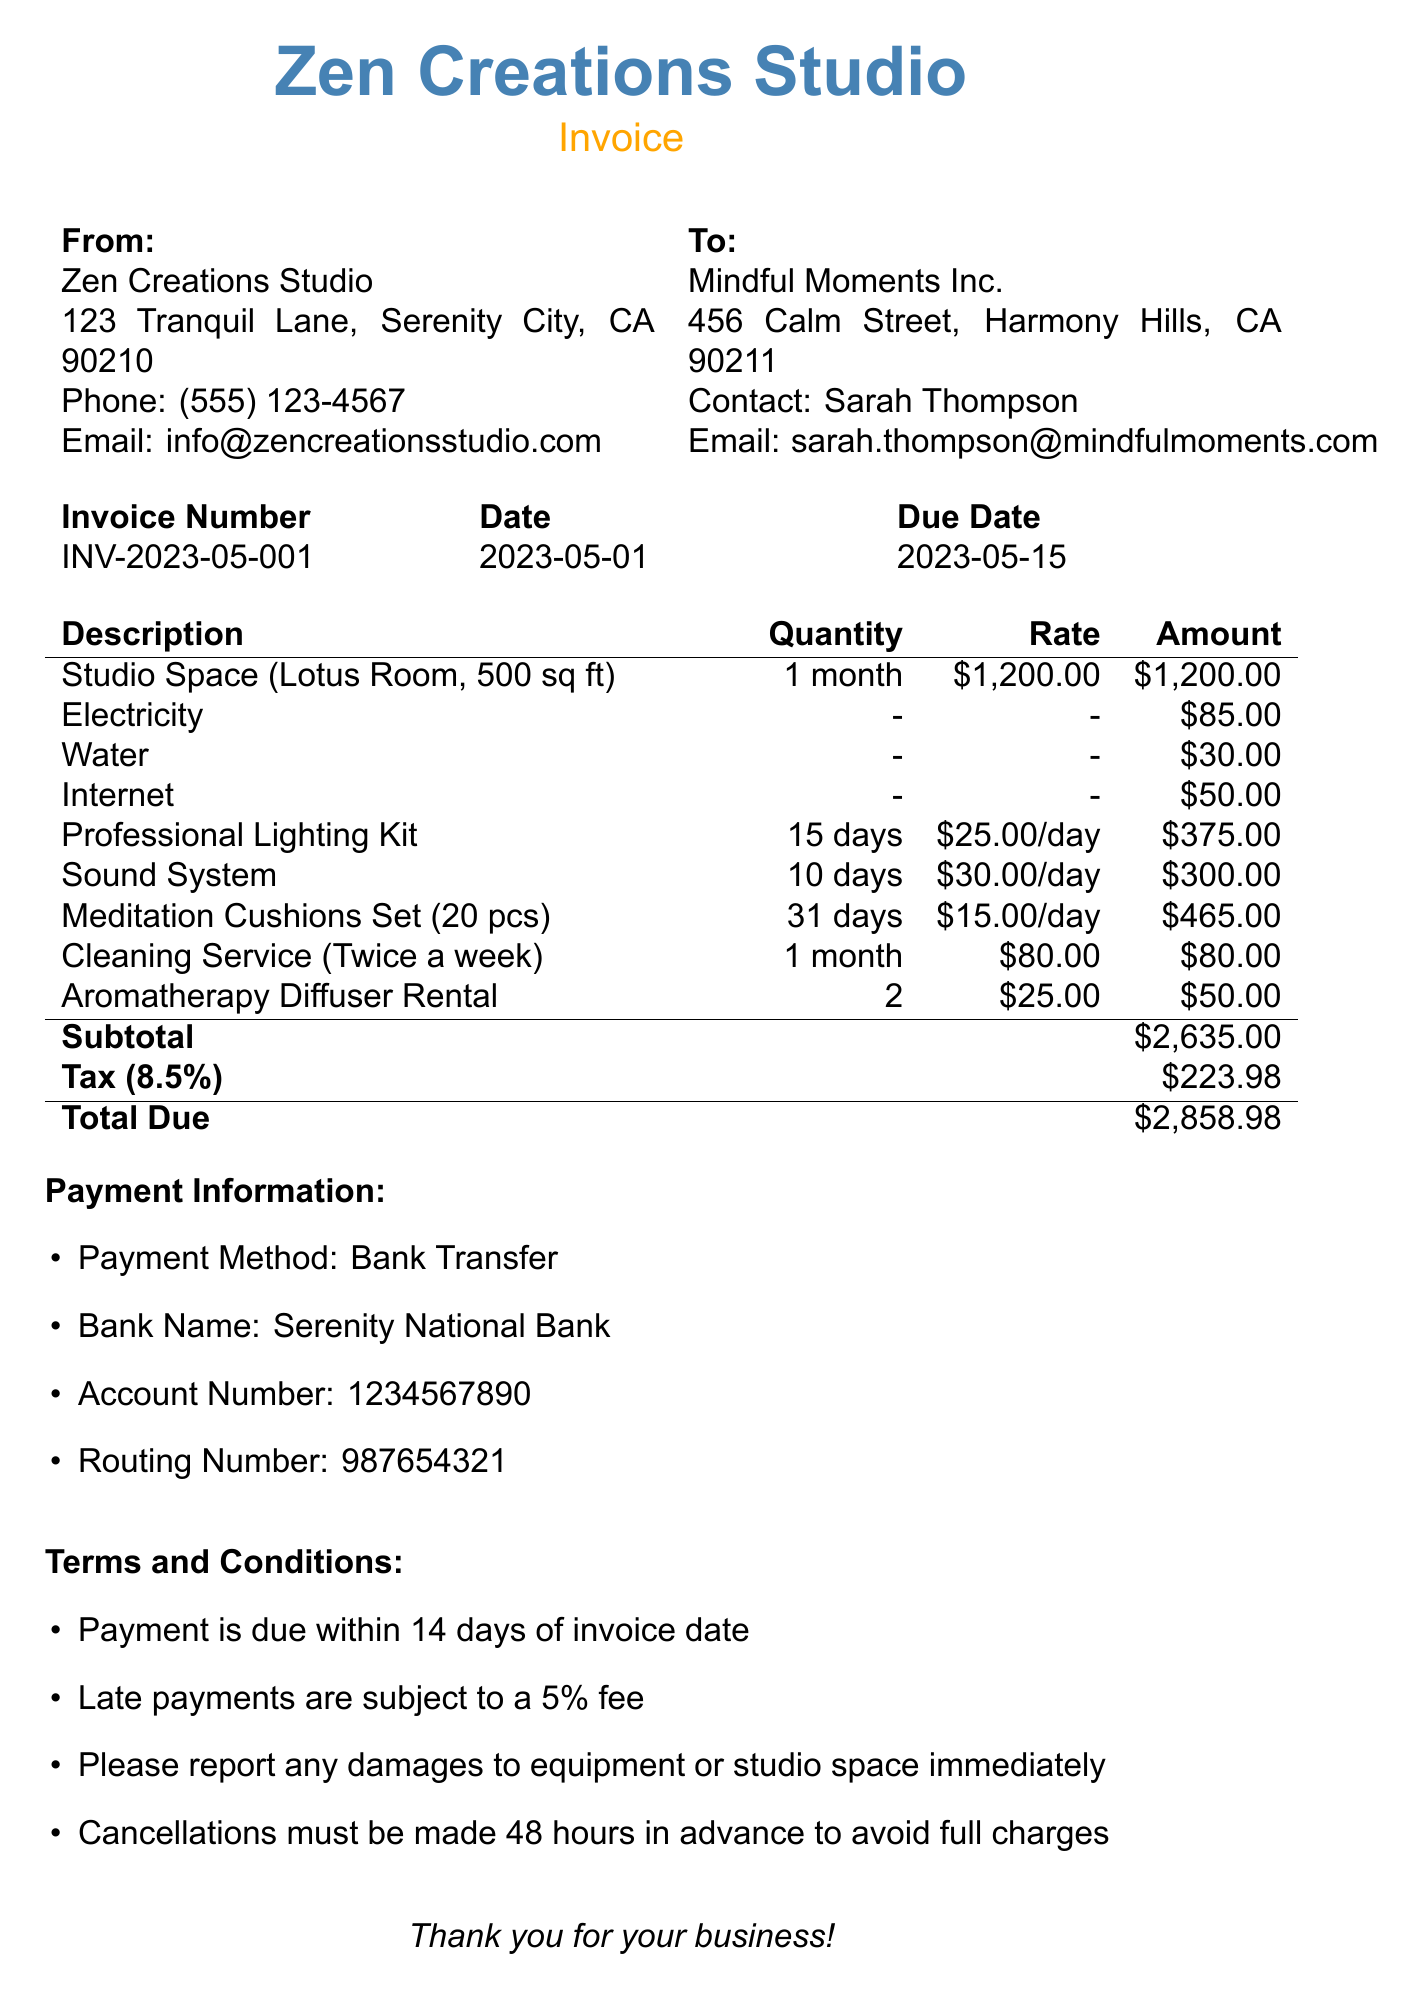What is the invoice number? The invoice number specified in the document is a unique identifier for the invoice, which is INV-2023-05-001.
Answer: INV-2023-05-001 What is the total due? The total due is the final amount after adding all costs and taxes specified on the invoice, which is $2,858.98.
Answer: $2,858.98 What is the rental period for the studio space? The rental period indicates the specific time frame for which the studio space is rented, which is May 1-31, 2023.
Answer: May 1-31, 2023 How much is the rate for the Sound System per day? The daily rate for using the Sound System is explicitly mentioned as $30.00 per day.
Answer: $30.00 What is the frequency of the Cleaning Service? The frequency describes how often the cleaning service is provided, which is specified as twice a week.
Answer: Twice a week What is the subtotal amount before tax? The subtotal amount is the total cost before adding tax, which is reflected as $2,635.00 in the document.
Answer: $2,635.00 What is the tax rate applied to the invoice? The tax rate is a percentage added to the subtotal, explicitly stated as 8.5%.
Answer: 8.5% What is the payment method listed in the invoice? The method of payment described in the document indicates how the client can pay the amount due, which is Bank Transfer.
Answer: Bank Transfer What should be done if there are damages to the equipment? This is a specific action required according to the terms and conditions, which states that damages should be reported immediately.
Answer: Report immediately 